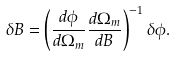<formula> <loc_0><loc_0><loc_500><loc_500>\delta B = \left ( \frac { d \phi } { d \Omega _ { m } } \frac { d \Omega _ { m } } { d B } \right ) ^ { - 1 } \delta \phi .</formula> 